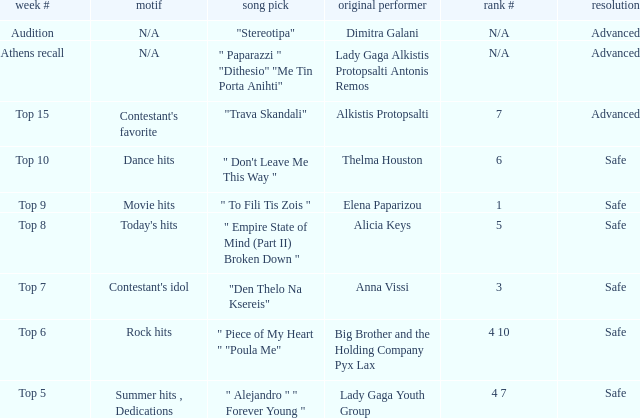What are all the order #s from the week "top 6"? 4 10. 